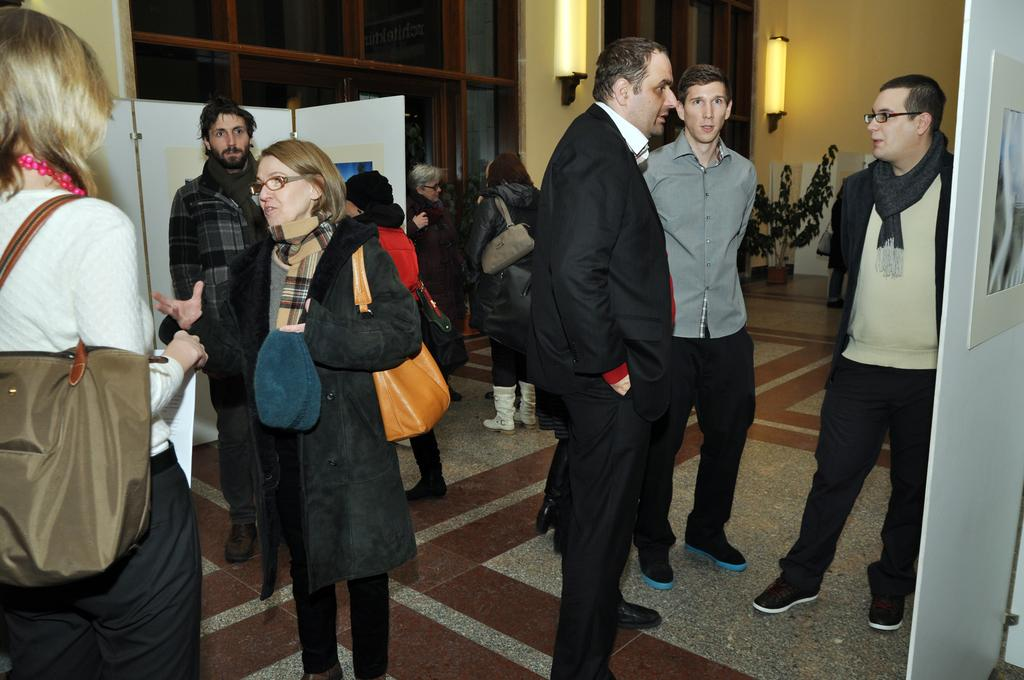What is the main subject of the image? The main subject of the image is a group of people standing. What objects can be seen attached to boards in the image? There are frames attached to boards in the image. What can be seen providing illumination in the image? There are lights visible in the image. What type of vegetation is present in the image? There is a plant in the image. What type of structure is visible in the image? There is a wall in the image. How many ears of corn can be seen growing on the wall in the image? There is no corn visible in the image; it features a group of people standing, frames attached to boards, lights, a plant, and a wall. 